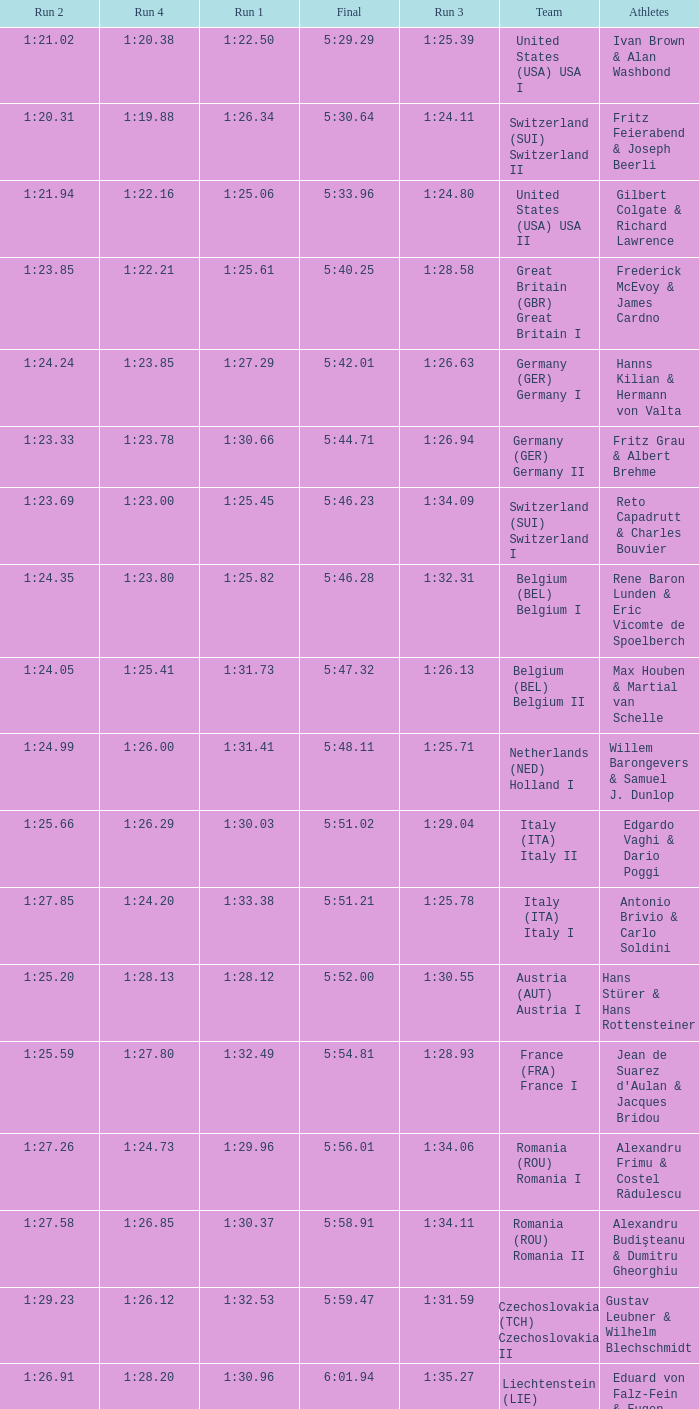Which Run 4 has Athletes of alexandru frimu & costel rădulescu? 1:24.73. 